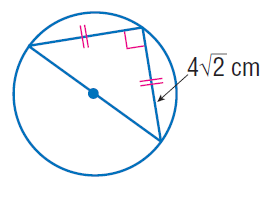Question: Find the exact circumference of the circle.
Choices:
A. 4 \pi
B. 4 \sqrt { 2 } \pi
C. 8 \pi
D. 16 \pi
Answer with the letter. Answer: C 